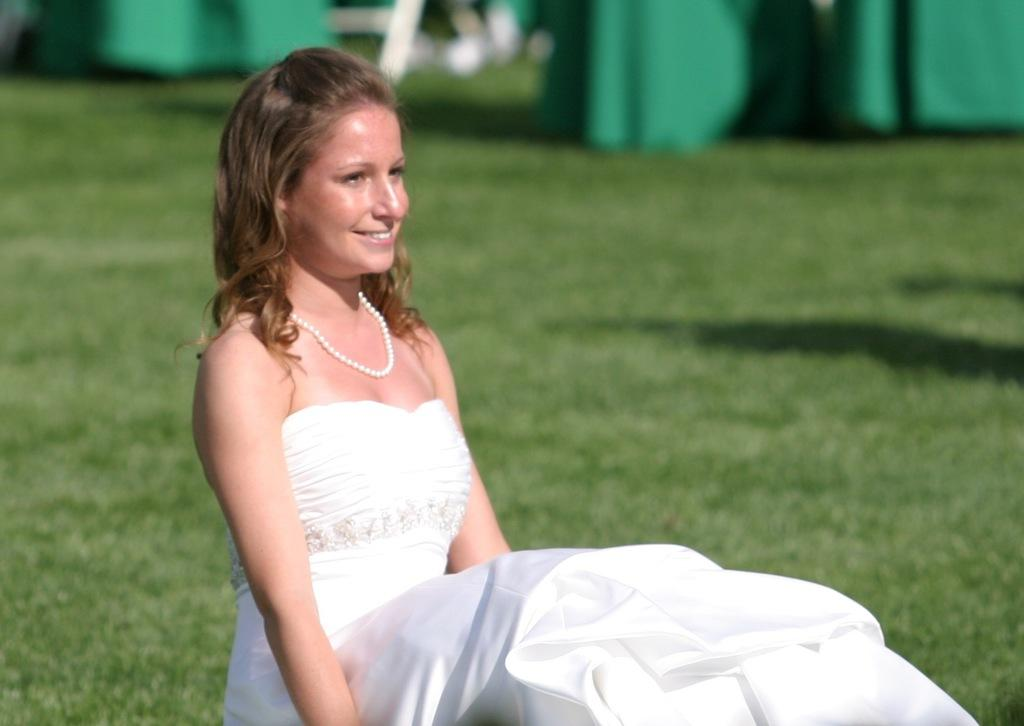Who is present in the image? There is a woman in the image. What is the woman's expression? The woman is smiling. What type of environment is visible in the background of the image? There is grass visible in the background of the image. What color are the objects in the background? There are green color objects in the background of the image. What type of mitten is the laborer wearing in the image? There is no laborer or mitten present in the image. How does the fireman extinguish the fire in the image? There is no fire or fireman present in the image. 